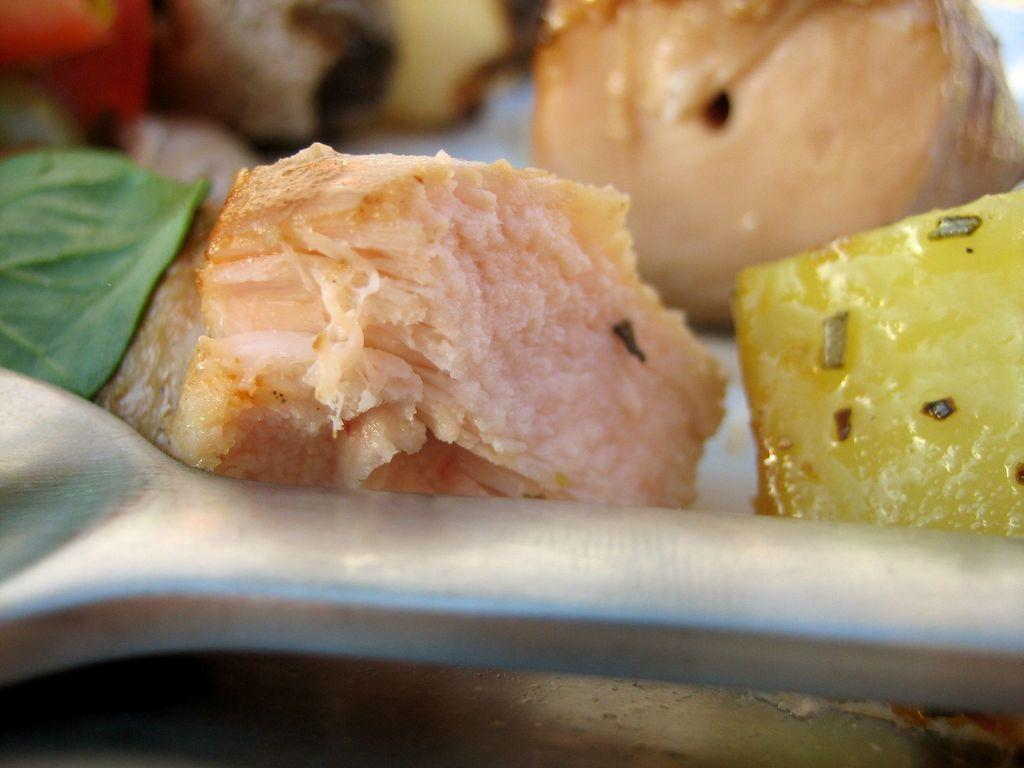What utensil is present in the image? There is a spoon in the image. What type of food items can be seen in the image? There are fruits in the image. What can be found on the left side of the image? There is a leaf on the left side of the image. Can you describe the food item visible in the background of the image? Unfortunately, the facts provided do not give enough information to describe the food item in the background. How many toes can be seen on the frogs in the image? There are no frogs present in the image, so it is not possible to determine the number of toes on any frogs. What type of bushes are visible in the image? There is no mention of bushes in the provided facts, so it is not possible to describe any bushes in the image. 